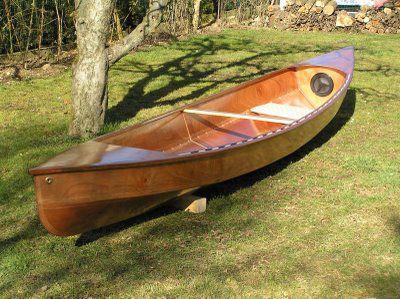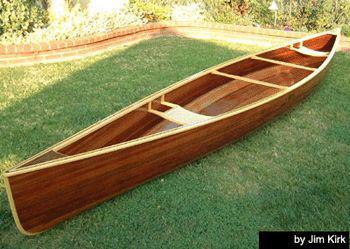The first image is the image on the left, the second image is the image on the right. Given the left and right images, does the statement "Each image shows a single prominent wooden boat, and the boats in the left and right images face the same general direction." hold true? Answer yes or no. Yes. 